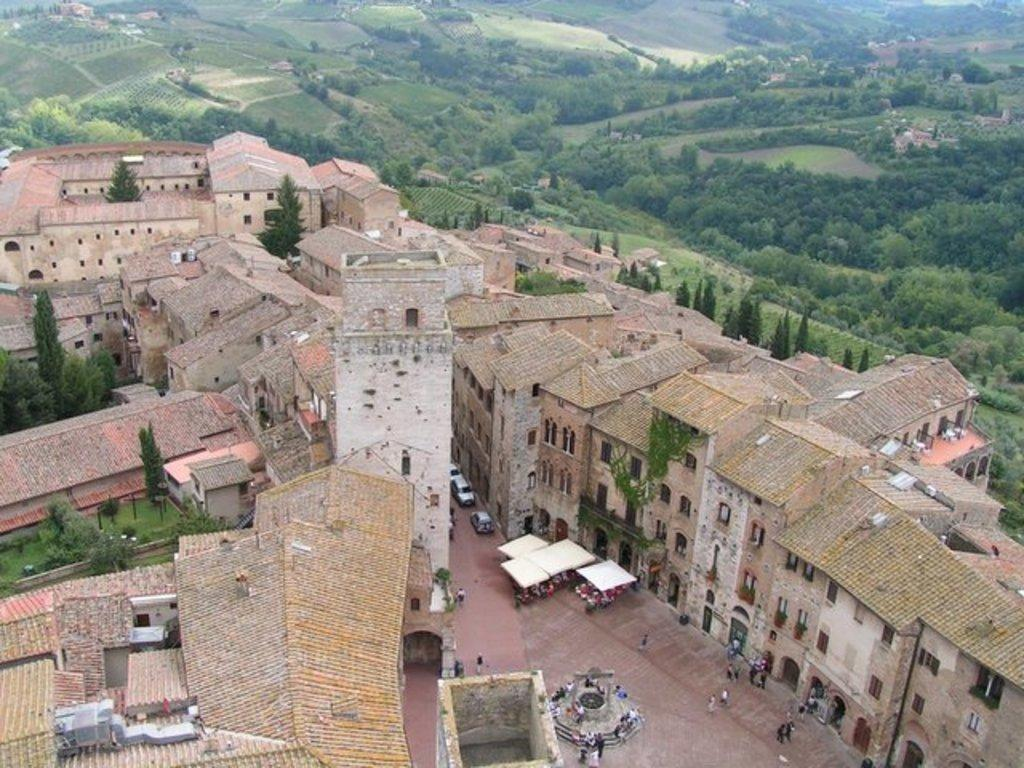What type of structures can be seen in the image? There are buildings in the image. What natural elements are present in the image? There are trees and grass in the image. What man-made objects can be seen in the image? There are vehicles in the image. Are there any living beings in the image? Yes, there are people in the image. What additional features can be seen in the image? There are tents in the image. What architectural details can be observed on the buildings? The buildings have windows and doors. What type of stage can be seen in the image? There is no stage present in the image. What reason might the people in the image have for being there? We cannot determine the reason for the people being in the image based on the provided facts. 